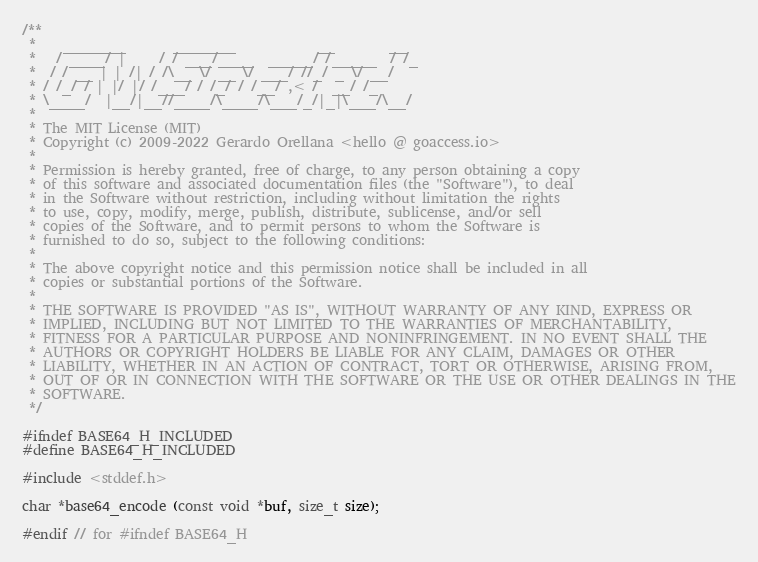<code> <loc_0><loc_0><loc_500><loc_500><_C_>/**
 *    _______       _______            __        __
 *   / ____/ |     / / ___/____  _____/ /_____  / /_
 *  / / __ | | /| / /\__ \/ __ \/ ___/ //_/ _ \/ __/
 * / /_/ / | |/ |/ /___/ / /_/ / /__/ ,< /  __/ /_
 * \____/  |__/|__//____/\____/\___/_/|_|\___/\__/
 *
 * The MIT License (MIT)
 * Copyright (c) 2009-2022 Gerardo Orellana <hello @ goaccess.io>
 *
 * Permission is hereby granted, free of charge, to any person obtaining a copy
 * of this software and associated documentation files (the "Software"), to deal
 * in the Software without restriction, including without limitation the rights
 * to use, copy, modify, merge, publish, distribute, sublicense, and/or sell
 * copies of the Software, and to permit persons to whom the Software is
 * furnished to do so, subject to the following conditions:
 *
 * The above copyright notice and this permission notice shall be included in all
 * copies or substantial portions of the Software.
 *
 * THE SOFTWARE IS PROVIDED "AS IS", WITHOUT WARRANTY OF ANY KIND, EXPRESS OR
 * IMPLIED, INCLUDING BUT NOT LIMITED TO THE WARRANTIES OF MERCHANTABILITY,
 * FITNESS FOR A PARTICULAR PURPOSE AND NONINFRINGEMENT. IN NO EVENT SHALL THE
 * AUTHORS OR COPYRIGHT HOLDERS BE LIABLE FOR ANY CLAIM, DAMAGES OR OTHER
 * LIABILITY, WHETHER IN AN ACTION OF CONTRACT, TORT OR OTHERWISE, ARISING FROM,
 * OUT OF OR IN CONNECTION WITH THE SOFTWARE OR THE USE OR OTHER DEALINGS IN THE
 * SOFTWARE.
 */

#ifndef BASE64_H_INCLUDED
#define BASE64_H_INCLUDED

#include <stddef.h>

char *base64_encode (const void *buf, size_t size);

#endif // for #ifndef BASE64_H
</code> 